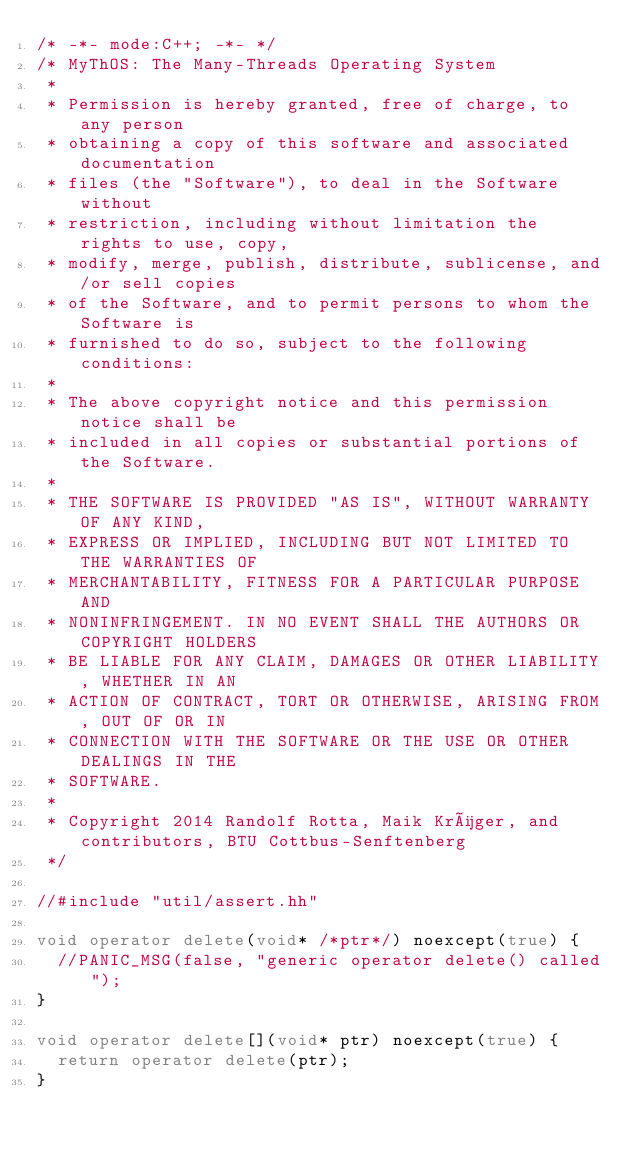<code> <loc_0><loc_0><loc_500><loc_500><_C++_>/* -*- mode:C++; -*- */
/* MyThOS: The Many-Threads Operating System
 *
 * Permission is hereby granted, free of charge, to any person
 * obtaining a copy of this software and associated documentation
 * files (the "Software"), to deal in the Software without
 * restriction, including without limitation the rights to use, copy,
 * modify, merge, publish, distribute, sublicense, and/or sell copies
 * of the Software, and to permit persons to whom the Software is
 * furnished to do so, subject to the following conditions:
 * 
 * The above copyright notice and this permission notice shall be
 * included in all copies or substantial portions of the Software.
 * 
 * THE SOFTWARE IS PROVIDED "AS IS", WITHOUT WARRANTY OF ANY KIND,
 * EXPRESS OR IMPLIED, INCLUDING BUT NOT LIMITED TO THE WARRANTIES OF
 * MERCHANTABILITY, FITNESS FOR A PARTICULAR PURPOSE AND
 * NONINFRINGEMENT. IN NO EVENT SHALL THE AUTHORS OR COPYRIGHT HOLDERS
 * BE LIABLE FOR ANY CLAIM, DAMAGES OR OTHER LIABILITY, WHETHER IN AN
 * ACTION OF CONTRACT, TORT OR OTHERWISE, ARISING FROM, OUT OF OR IN
 * CONNECTION WITH THE SOFTWARE OR THE USE OR OTHER DEALINGS IN THE
 * SOFTWARE.
 * 
 * Copyright 2014 Randolf Rotta, Maik Krüger, and contributors, BTU Cottbus-Senftenberg 
 */

//#include "util/assert.hh"

void operator delete(void* /*ptr*/) noexcept(true) {
  //PANIC_MSG(false, "generic operator delete() called");
}

void operator delete[](void* ptr) noexcept(true) {
  return operator delete(ptr);
}
</code> 